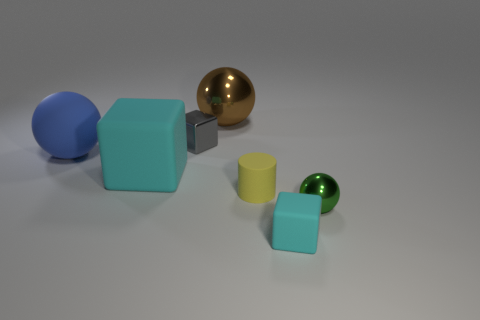Subtract all gray blocks. How many blocks are left? 2 Subtract all cyan cylinders. How many cyan blocks are left? 2 Add 1 yellow cylinders. How many objects exist? 8 Subtract all green balls. How many balls are left? 2 Subtract all cylinders. How many objects are left? 6 Subtract all yellow spheres. Subtract all brown cubes. How many spheres are left? 3 Add 1 metallic cubes. How many metallic cubes exist? 2 Subtract 0 blue blocks. How many objects are left? 7 Subtract all large shiny balls. Subtract all brown metallic objects. How many objects are left? 5 Add 3 big cubes. How many big cubes are left? 4 